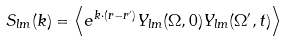Convert formula to latex. <formula><loc_0><loc_0><loc_500><loc_500>S _ { l m } ( k ) = \left < e ^ { { k } \cdot ( { r - { r ^ { \prime } } } ) } Y _ { l m } ( \Omega , 0 ) Y _ { l m } ( \Omega ^ { \prime } , t ) \right ></formula> 